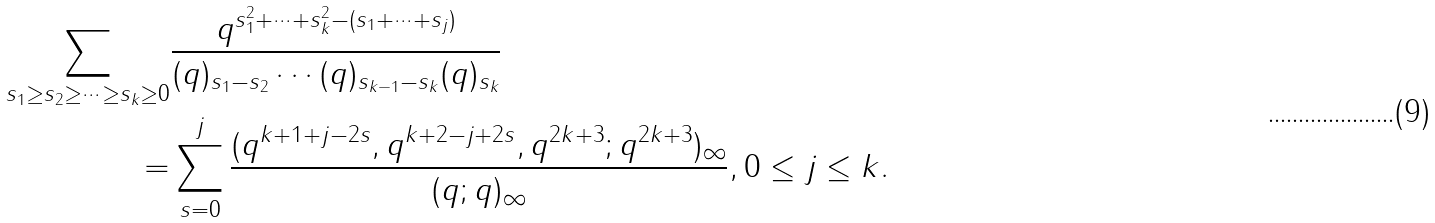<formula> <loc_0><loc_0><loc_500><loc_500>\sum _ { s _ { 1 } \geq s _ { 2 } \geq \cdots \geq s _ { k } \geq 0 } & \frac { q ^ { s _ { 1 } ^ { 2 } + \cdots + s _ { k } ^ { 2 } - ( s _ { 1 } + \cdots + s _ { j } ) } } { ( q ) _ { s _ { 1 } - s _ { 2 } } \cdots ( q ) _ { s _ { k - 1 } - s _ { k } } ( q ) _ { s _ { k } } } \\ = & \sum _ { s = 0 } ^ { j } \frac { ( q ^ { k + 1 + j - 2 s } , q ^ { k + 2 - j + 2 s } , q ^ { 2 k + 3 } ; q ^ { 2 k + 3 } ) _ { \infty } } { ( q ; q ) _ { \infty } } , 0 \leq j \leq k .</formula> 